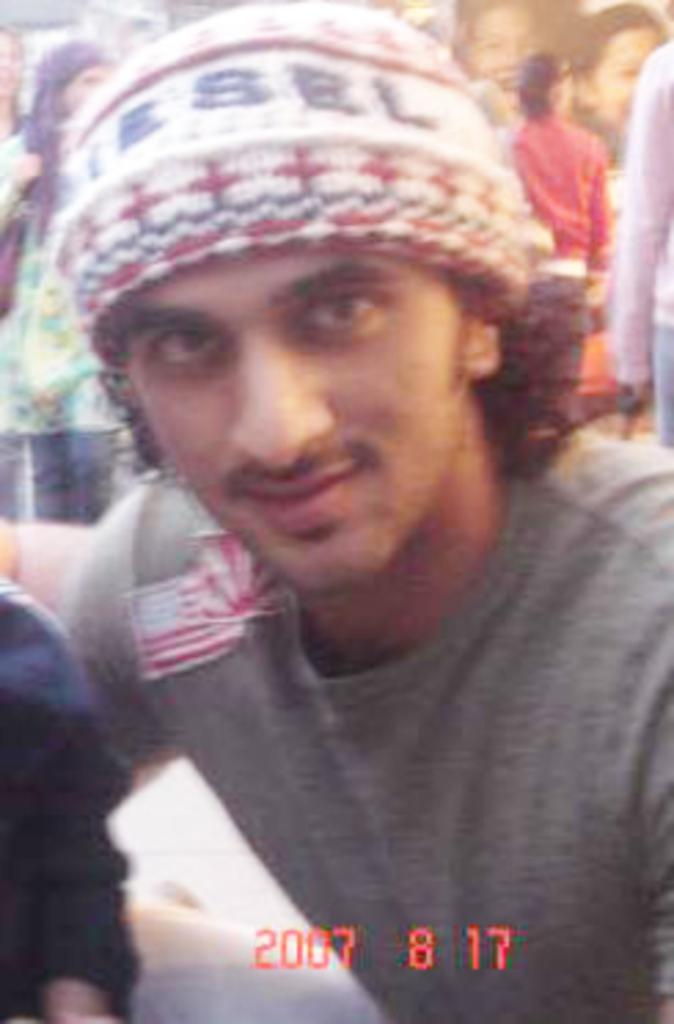What is the person in the image wearing on their head? The person in the image is wearing a cap. What color is the t-shirt the person is wearing? The person is wearing a grey t-shirt. Can you describe the other people present in the image? Unfortunately, the provided facts do not give any information about the other people in the image. What information is mentioned at the bottom of the image? The date is mentioned at the bottom of the image. What type of box is the person holding in the image? There is no box present in the image. How does the person feel about wearing the cap in the image? The provided facts do not give any information about the person's feelings or emotions. 